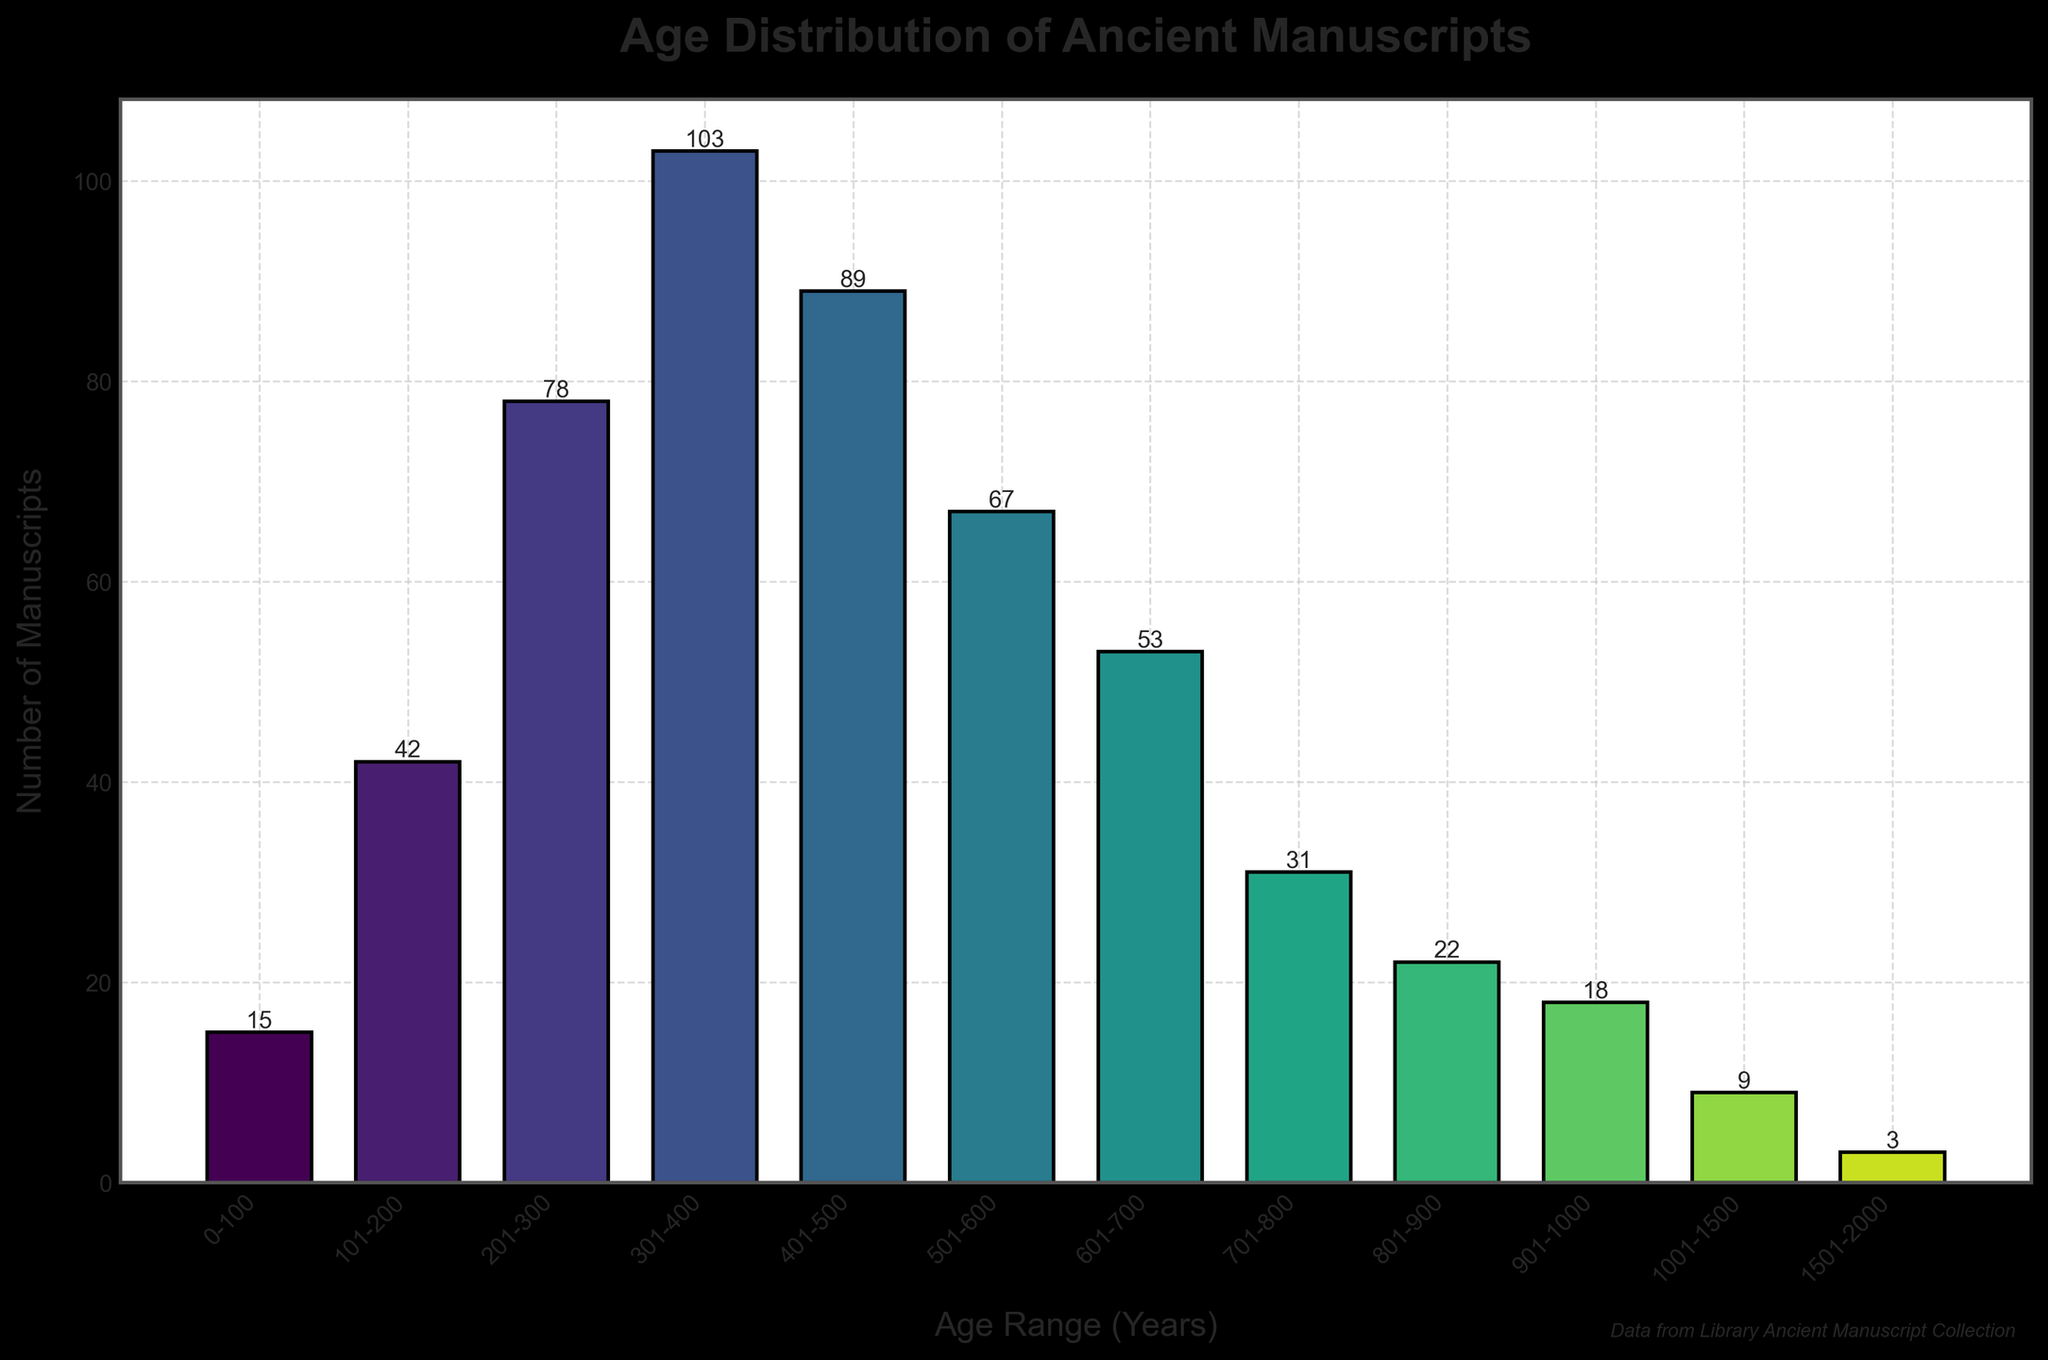what is the age range with the highest number of manuscripts? Looking at the histogram, the tallest bar represents the age range with the most manuscripts. The highest bar corresponds to the age range 301-400 years with 103 manuscripts.
Answer: 301-400 years How many age ranges have fewer than 20 manuscripts? Observing the histogram, the bars that reach fewer than 20 manuscripts are 901-1000 years, 1001-1500 years, and 1501-2000 years. These total to 3 age ranges.
Answer: 3 What is the total number of manuscripts in the age ranges from 0-500 years? To find the total number of manuscripts in the specified age ranges, we add the numbers of manuscripts for each range from 0-500 years. 15 (0-100) + 42 (101-200) + 78 (201-300) + 103 (301-400) + 89 (401-500) = 327 manuscripts.
Answer: 327 Compare the number of manuscripts in the 401-500 years range to the 601-700 years range. Which is greater? By comparing the heights of the corresponding bars in the histogram, the 401-500 years range has 89 manuscripts and the 601-700 years range has 53 manuscripts. 89 is greater than 53.
Answer: 401-500 years What is the average number of manuscripts per age range? To find the average, sum all the manuscripts and divide by the number of age ranges. The total sum is 530, and there are 12 age ranges, so the average is 530 / 12 = 44.17 manuscripts.
Answer: 44.17 Which age range has the fewest manuscripts, and how many does it have? The shortest bar in the histogram represents the age range with the fewest manuscripts. The bar for the 1501-2000 years range is the lowest with 3 manuscripts.
Answer: 1501-2000 years, 3 How many age ranges have more than 50 manuscripts? By counting the bars in the histogram where the number of manuscripts exceeds 50, the eligible ranges are: 201-300, 301-400, 401-500, 501-600, and 601-700. This totals to 5 age ranges.
Answer: 5 